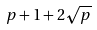Convert formula to latex. <formula><loc_0><loc_0><loc_500><loc_500>p + 1 + 2 \sqrt { p }</formula> 